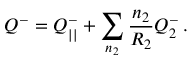Convert formula to latex. <formula><loc_0><loc_0><loc_500><loc_500>Q ^ { - } = Q _ { | | } ^ { - } + \sum _ { n _ { 2 } } \frac { n _ { 2 } } { R _ { 2 } } Q _ { 2 } ^ { - } \, .</formula> 